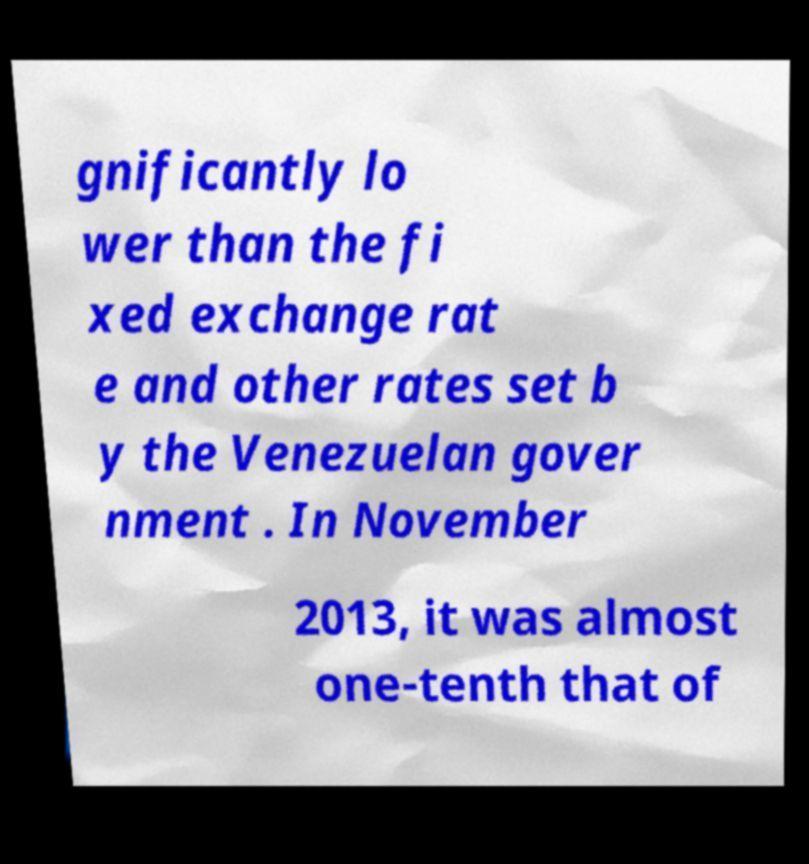Can you read and provide the text displayed in the image?This photo seems to have some interesting text. Can you extract and type it out for me? gnificantly lo wer than the fi xed exchange rat e and other rates set b y the Venezuelan gover nment . In November 2013, it was almost one-tenth that of 